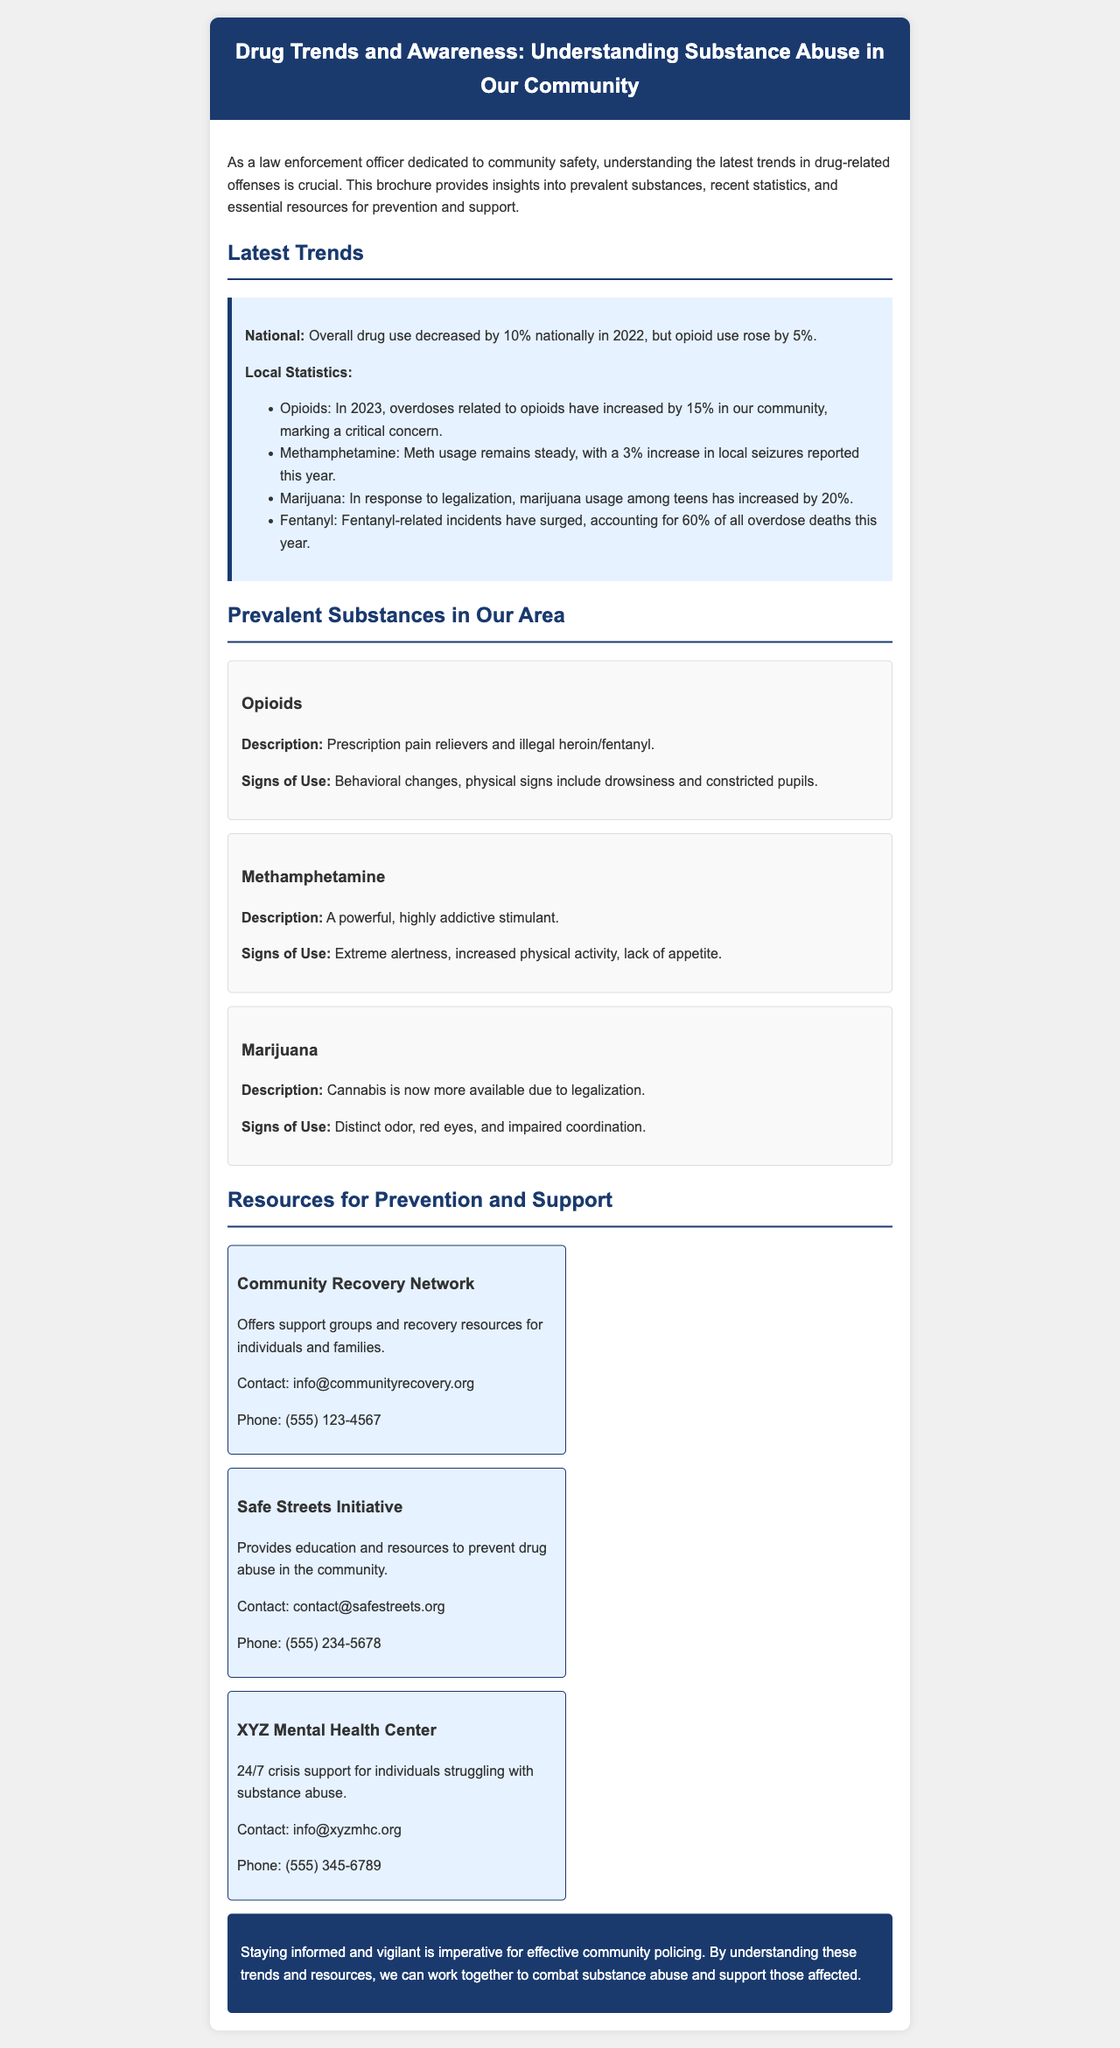What was the percentage decrease in overall drug use nationally in 2022? The document states that overall drug use decreased by 10% nationally in 2022.
Answer: 10% What is the increase in opioid-related overdoses in our community for 2023? According to the brochure, overdoses related to opioids have increased by 15% in 2023.
Answer: 15% What percentage of overdose deaths this year are related to fentanyl? The document specifies that fentanyl-related incidents account for 60% of all overdose deaths this year.
Answer: 60% What substance showed a 20% increase in usage among teens? The brochure mentions that marijuana usage among teens has increased by 20% in response to legalization.
Answer: Marijuana What type of support does the Community Recovery Network offer? The brochure indicates that the Community Recovery Network offers support groups and recovery resources for individuals and families.
Answer: Support groups How many resource organizations are listed in the brochure? The document lists three resource organizations for prevention and support.
Answer: Three Which substance is described as having a strong odor, red eyes, and impaired coordination as signs of use? The signs of use mentioned for marijuana include a distinct odor, red eyes, and impaired coordination.
Answer: Marijuana What is the contact phone number for the XYZ Mental Health Center? The brochure provides the contact phone number for XYZ Mental Health Center as (555) 345-6789.
Answer: (555) 345-6789 What is the main purpose of this brochure? The document states that the main purpose is to provide insights into prevalent substances, recent statistics, and essential resources for prevention and support.
Answer: Educational resource 